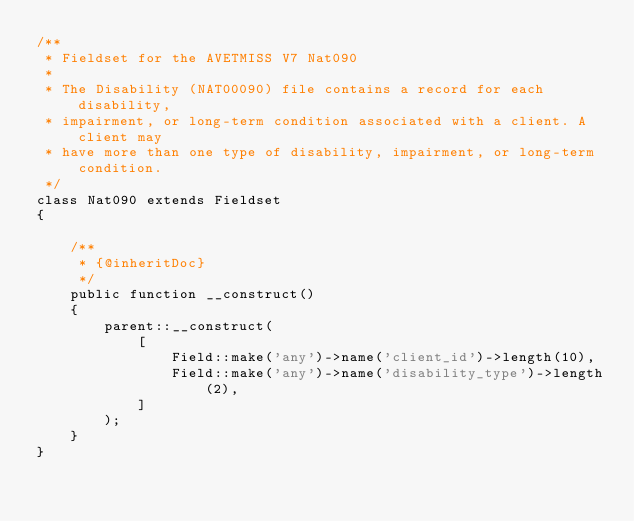<code> <loc_0><loc_0><loc_500><loc_500><_PHP_>/**
 * Fieldset for the AVETMISS V7 Nat090
 *
 * The Disability (NAT00090) file contains a record for each disability,
 * impairment, or long-term condition associated with a client. A client may
 * have more than one type of disability, impairment, or long-term condition.
 */
class Nat090 extends Fieldset
{

    /**
     * {@inheritDoc}
     */
    public function __construct()
    {
        parent::__construct(
            [
                Field::make('any')->name('client_id')->length(10),
                Field::make('any')->name('disability_type')->length(2),
            ]
        );
    }
}
</code> 